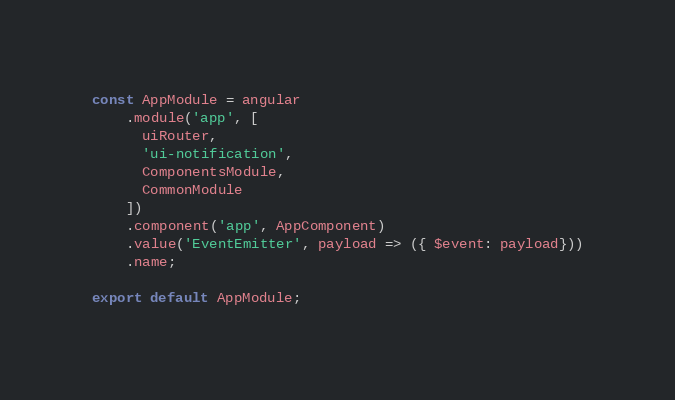Convert code to text. <code><loc_0><loc_0><loc_500><loc_500><_JavaScript_>const AppModule = angular
    .module('app', [
      uiRouter,
      'ui-notification',
      ComponentsModule,
      CommonModule
    ])
    .component('app', AppComponent)
    .value('EventEmitter', payload => ({ $event: payload}))
    .name;

export default AppModule;
</code> 